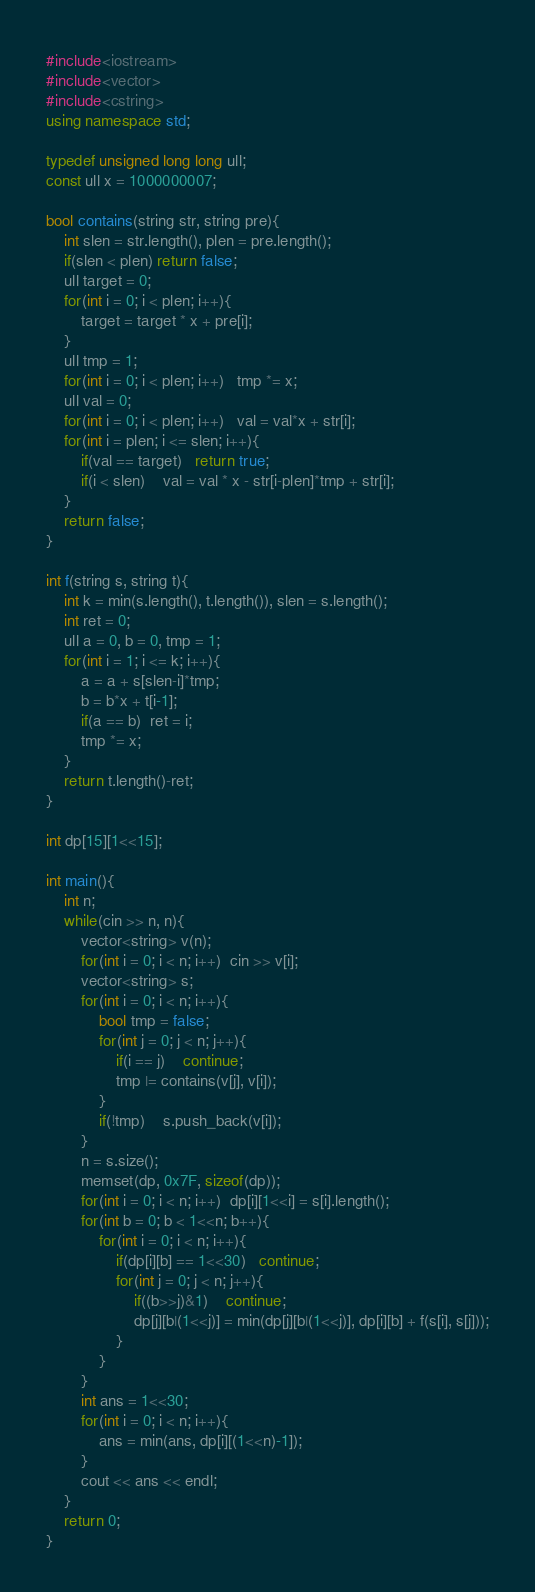<code> <loc_0><loc_0><loc_500><loc_500><_C++_>#include<iostream>
#include<vector>
#include<cstring>
using namespace std;

typedef unsigned long long ull;
const ull x = 1000000007;

bool contains(string str, string pre){
    int slen = str.length(), plen = pre.length();
    if(slen < plen) return false;
    ull target = 0;
    for(int i = 0; i < plen; i++){
        target = target * x + pre[i];
    }
    ull tmp = 1;
    for(int i = 0; i < plen; i++)   tmp *= x;
    ull val = 0;
    for(int i = 0; i < plen; i++)   val = val*x + str[i];
    for(int i = plen; i <= slen; i++){
        if(val == target)   return true;
        if(i < slen)    val = val * x - str[i-plen]*tmp + str[i];
    }
    return false;
}

int f(string s, string t){
    int k = min(s.length(), t.length()), slen = s.length();
    int ret = 0;
    ull a = 0, b = 0, tmp = 1;
    for(int i = 1; i <= k; i++){
        a = a + s[slen-i]*tmp;
        b = b*x + t[i-1];
        if(a == b)  ret = i;
        tmp *= x;
    }
    return t.length()-ret;
}

int dp[15][1<<15];

int main(){
    int n;
    while(cin >> n, n){
        vector<string> v(n);
        for(int i = 0; i < n; i++)  cin >> v[i];
        vector<string> s;
        for(int i = 0; i < n; i++){
            bool tmp = false;
            for(int j = 0; j < n; j++){
                if(i == j)    continue;
                tmp |= contains(v[j], v[i]);
            }
            if(!tmp)    s.push_back(v[i]);
        }
        n = s.size();
        memset(dp, 0x7F, sizeof(dp));
        for(int i = 0; i < n; i++)  dp[i][1<<i] = s[i].length();
        for(int b = 0; b < 1<<n; b++){
            for(int i = 0; i < n; i++){
                if(dp[i][b] == 1<<30)   continue;
                for(int j = 0; j < n; j++){
                    if((b>>j)&1)    continue;
                    dp[j][b|(1<<j)] = min(dp[j][b|(1<<j)], dp[i][b] + f(s[i], s[j]));
                }
            }
        }
        int ans = 1<<30;
        for(int i = 0; i < n; i++){
            ans = min(ans, dp[i][(1<<n)-1]);
        }
        cout << ans << endl;
    }
    return 0;
}

</code> 